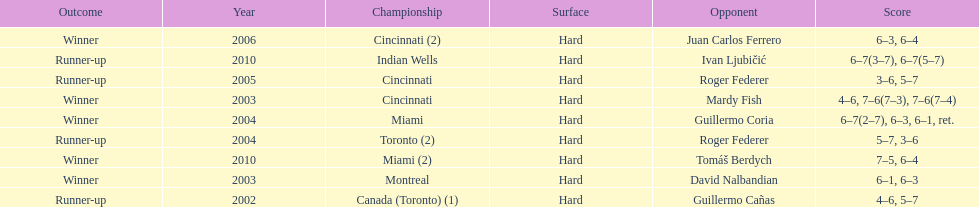How many times was roger federer a runner-up? 2. Can you give me this table as a dict? {'header': ['Outcome', 'Year', 'Championship', 'Surface', 'Opponent', 'Score'], 'rows': [['Winner', '2006', 'Cincinnati (2)', 'Hard', 'Juan Carlos Ferrero', '6–3, 6–4'], ['Runner-up', '2010', 'Indian Wells', 'Hard', 'Ivan Ljubičić', '6–7(3–7), 6–7(5–7)'], ['Runner-up', '2005', 'Cincinnati', 'Hard', 'Roger Federer', '3–6, 5–7'], ['Winner', '2003', 'Cincinnati', 'Hard', 'Mardy Fish', '4–6, 7–6(7–3), 7–6(7–4)'], ['Winner', '2004', 'Miami', 'Hard', 'Guillermo Coria', '6–7(2–7), 6–3, 6–1, ret.'], ['Runner-up', '2004', 'Toronto (2)', 'Hard', 'Roger Federer', '5–7, 3–6'], ['Winner', '2010', 'Miami (2)', 'Hard', 'Tomáš Berdych', '7–5, 6–4'], ['Winner', '2003', 'Montreal', 'Hard', 'David Nalbandian', '6–1, 6–3'], ['Runner-up', '2002', 'Canada (Toronto) (1)', 'Hard', 'Guillermo Cañas', '4–6, 5–7']]} 